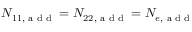<formula> <loc_0><loc_0><loc_500><loc_500>N _ { 1 1 , { a d d } } = N _ { 2 2 , { a d d } } = N _ { e , { a d d } }</formula> 